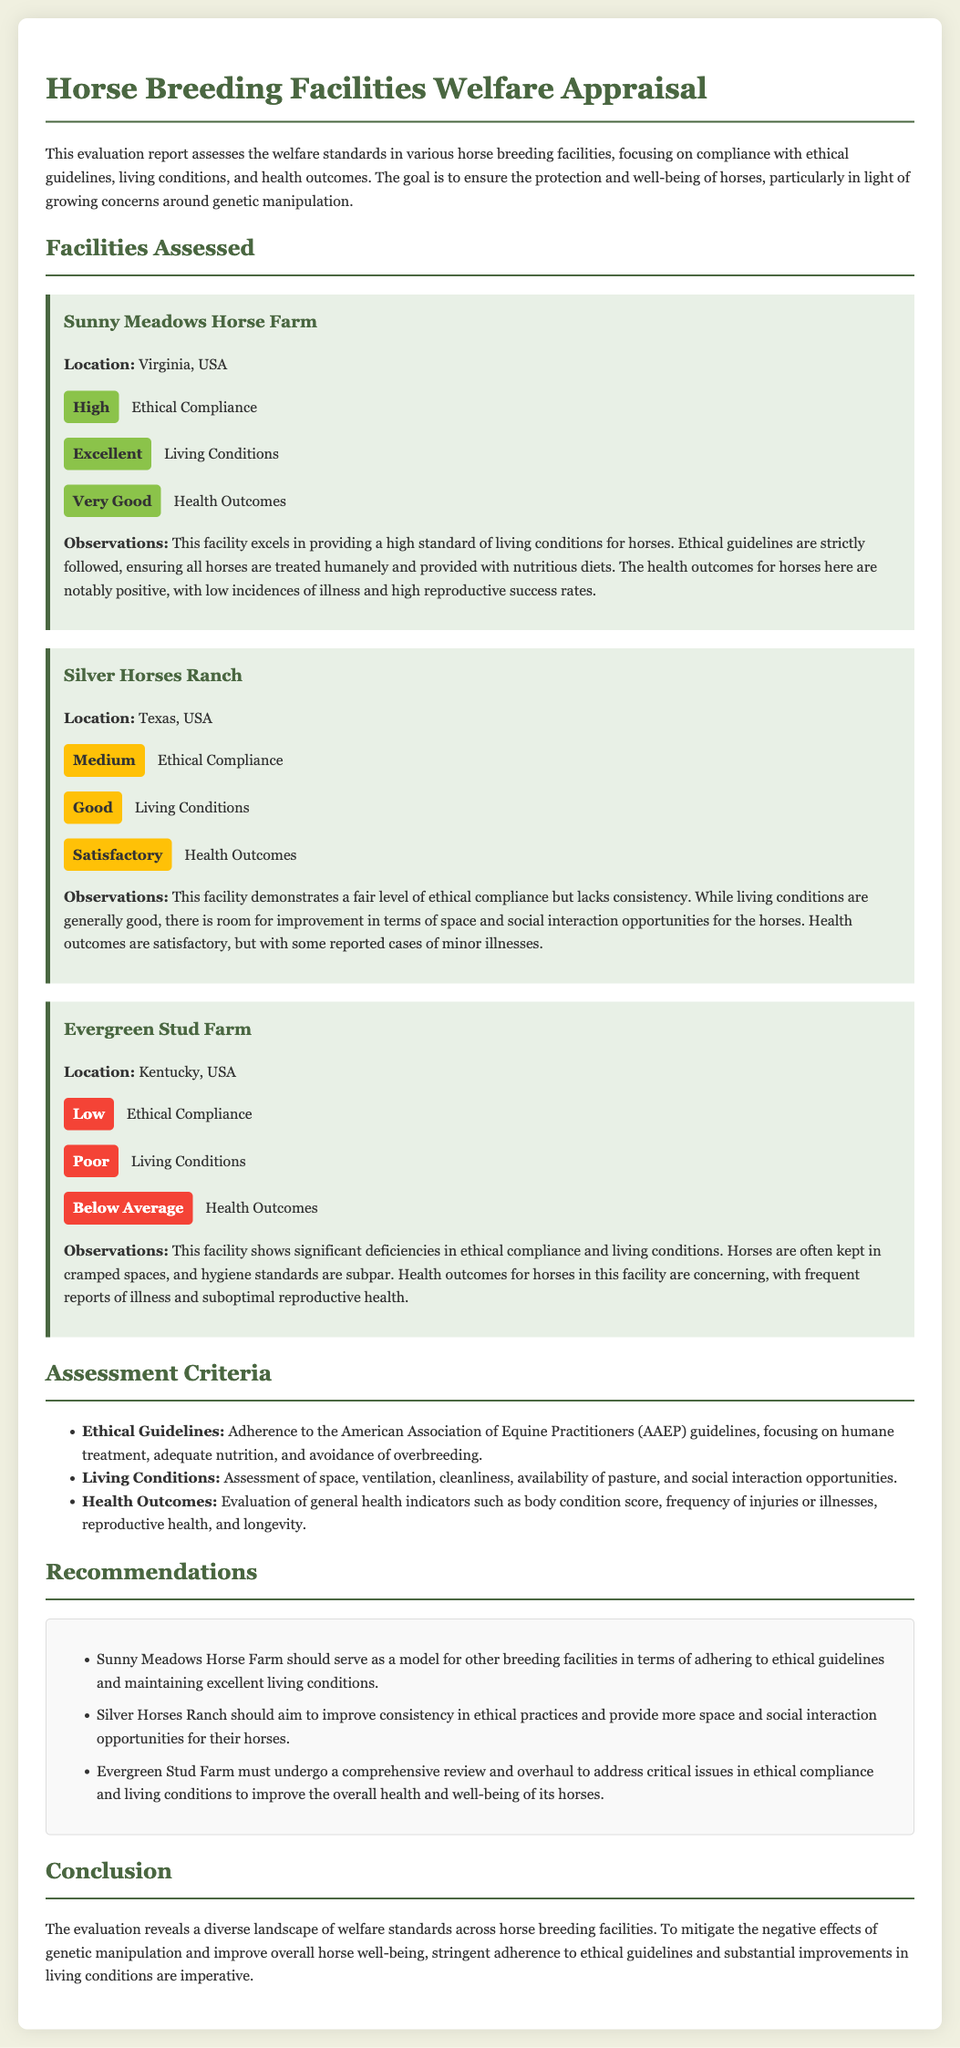What is the name of the first facility assessed? The first facility assessed is specifically mentioned by name, which is "Sunny Meadows Horse Farm."
Answer: Sunny Meadows Horse Farm What rating did Evergreen Stud Farm receive for ethical compliance? The document lists the ethical compliance rating for Evergreen Stud Farm, which is "Low."
Answer: Low How many facilities are assessed in the report? The document specifies a section where it lists the facilities assessed, showing there are three facilities evaluated in total.
Answer: Three What is the observed issue at Silver Horses Ranch? The observations for Silver Horses Ranch highlight that there is "room for improvement in terms of space and social interaction opportunities for the horses."
Answer: Space and social interaction What should Evergreen Stud Farm undergo to improve conditions? The recommendations section suggests that Evergreen Stud Farm must "undergo a comprehensive review and overhaul" to address its issues.
Answer: Comprehensive review and overhaul What is the overall health outcome rating for Sunny Meadows Horse Farm? The document clearly states that health outcomes for Sunny Meadows Horse Farm are rated as "Very Good."
Answer: Very Good What ethical guideline criteria is emphasized in the report? The assessment criteria highlight the focus on "humane treatment, adequate nutrition, and avoidance of overbreeding" as part of the ethical guidelines.
Answer: Humane treatment, adequate nutrition, and avoidance of overbreeding Which facility is recommended to serve as a model for others? The recommendations section explicitly states that "Sunny Meadows Horse Farm should serve as a model for other breeding facilities."
Answer: Sunny Meadows Horse Farm What is the conclusion regarding genetic manipulation? The conclusion mentions the necessity of adhering to ethical guidelines to "mitigate the negative effects of genetic manipulation."
Answer: Mitigate the negative effects of genetic manipulation 